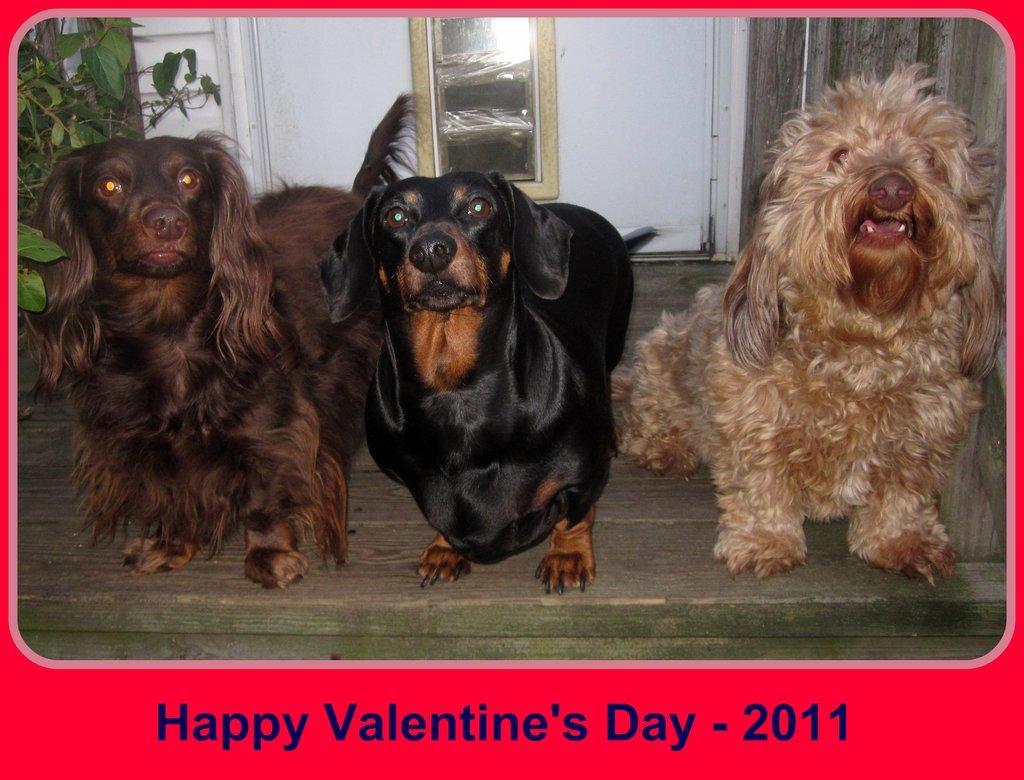How would you summarize this image in a sentence or two? In this picture I can see few dogs on the wooden surface and the image has borders with some text. 